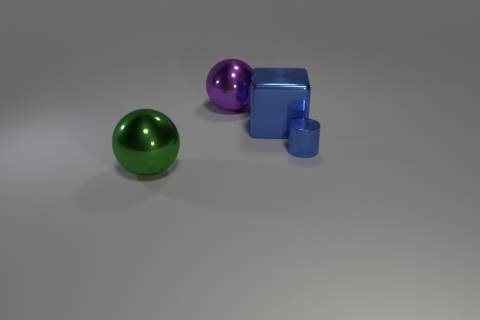How many yellow metallic spheres have the same size as the green metal ball?
Offer a very short reply. 0. There is a blue thing that is in front of the blue thing that is to the left of the tiny cylinder; what size is it?
Your answer should be compact. Small. There is a big blue shiny thing right of the green metal ball; is its shape the same as the blue thing that is in front of the blue block?
Keep it short and to the point. No. The thing that is both in front of the blue metallic block and to the left of the tiny blue cylinder is what color?
Offer a very short reply. Green. Is there a cylinder that has the same color as the small thing?
Keep it short and to the point. No. What is the color of the ball to the right of the green shiny sphere?
Your answer should be very brief. Purple. Is there a small cylinder that is right of the metal ball right of the large green metallic sphere?
Ensure brevity in your answer.  Yes. There is a cylinder; is it the same color as the object to the left of the purple object?
Ensure brevity in your answer.  No. Are there any blue things that have the same material as the green object?
Make the answer very short. Yes. How many small blue cylinders are there?
Offer a very short reply. 1. 